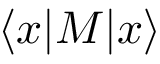<formula> <loc_0><loc_0><loc_500><loc_500>\langle x | M | x \rangle</formula> 